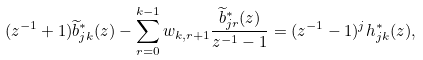Convert formula to latex. <formula><loc_0><loc_0><loc_500><loc_500>( z ^ { - 1 } + 1 ) \widetilde { b } _ { j k } ^ { * } ( z ) - \sum _ { r = 0 } ^ { k - 1 } w _ { k , r + 1 } \frac { \widetilde { b } _ { j r } ^ { * } ( z ) } { z ^ { - 1 } - 1 } = ( z ^ { - 1 } - 1 ) ^ { j } h _ { j k } ^ { * } ( z ) ,</formula> 